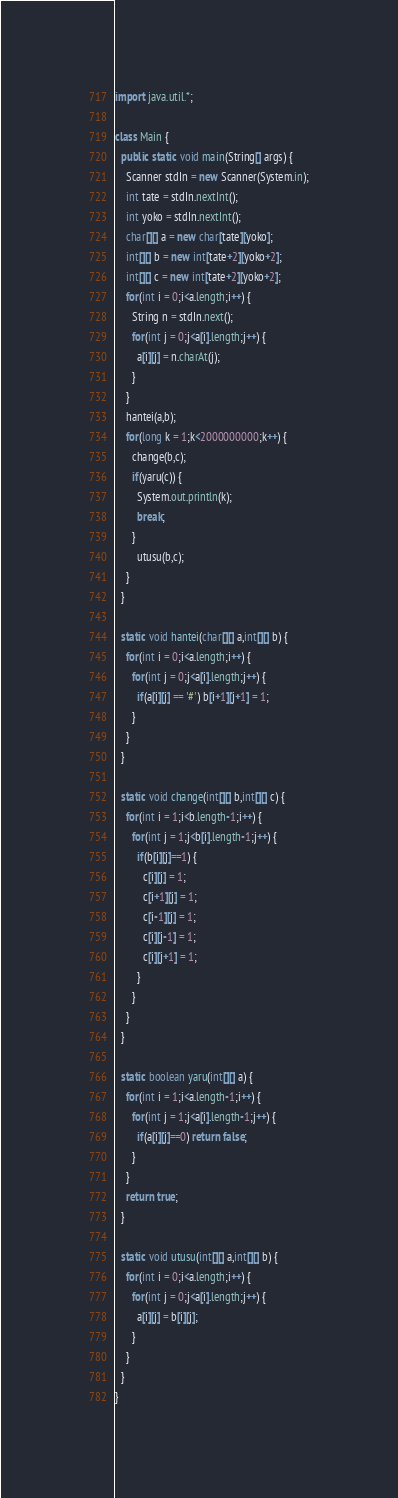Convert code to text. <code><loc_0><loc_0><loc_500><loc_500><_Java_>import java.util.*;

class Main {
  public static void main(String[] args) {
    Scanner stdIn = new Scanner(System.in);
    int tate = stdIn.nextInt();
    int yoko = stdIn.nextInt();
    char[][] a = new char[tate][yoko];
    int[][] b = new int[tate+2][yoko+2];
    int[][] c = new int[tate+2][yoko+2];
    for(int i = 0;i<a.length;i++) {
      String n = stdIn.next();
      for(int j = 0;j<a[i].length;j++) {
        a[i][j] = n.charAt(j);
      }
    }
    hantei(a,b);
    for(long k = 1;k<2000000000;k++) {
      change(b,c);
      if(yaru(c)) {
        System.out.println(k);
        break;
      }
        utusu(b,c);
    }
  }

  static void hantei(char[][] a,int[][] b) {
    for(int i = 0;i<a.length;i++) {
      for(int j = 0;j<a[i].length;j++) {
        if(a[i][j] == '#') b[i+1][j+1] = 1;
      }
    }
  }

  static void change(int[][] b,int[][] c) {
    for(int i = 1;i<b.length-1;i++) {
      for(int j = 1;j<b[i].length-1;j++) {
        if(b[i][j]==1) {
          c[i][j] = 1;
          c[i+1][j] = 1;
          c[i-1][j] = 1;
          c[i][j-1] = 1;
          c[i][j+1] = 1;
        }
      }
    }
  }

  static boolean yaru(int[][] a) {
    for(int i = 1;i<a.length-1;i++) {
      for(int j = 1;j<a[i].length-1;j++) {
        if(a[i][j]==0) return false;
      }
    }
    return true;
  }

  static void utusu(int[][] a,int[][] b) {
    for(int i = 0;i<a.length;i++) {
      for(int j = 0;j<a[i].length;j++) {
        a[i][j] = b[i][j];
      }
    }
  }
}</code> 